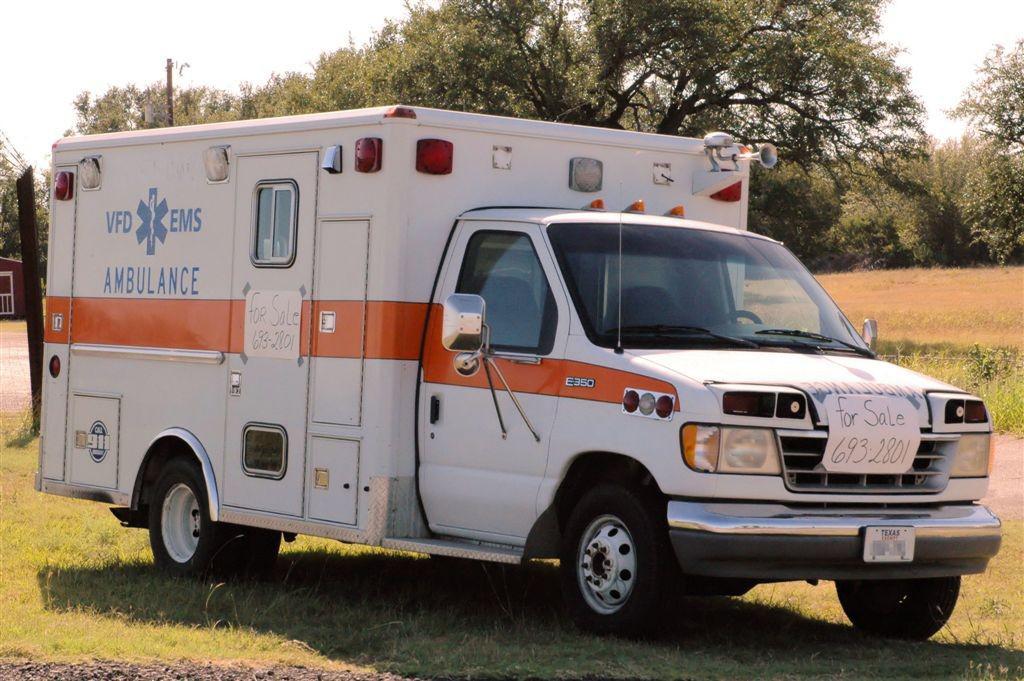What kind of emergency vehicle is this?
Provide a short and direct response. Ambulance. What phone number should you call to buy this ambulance?
Your answer should be very brief. 693-2801. 